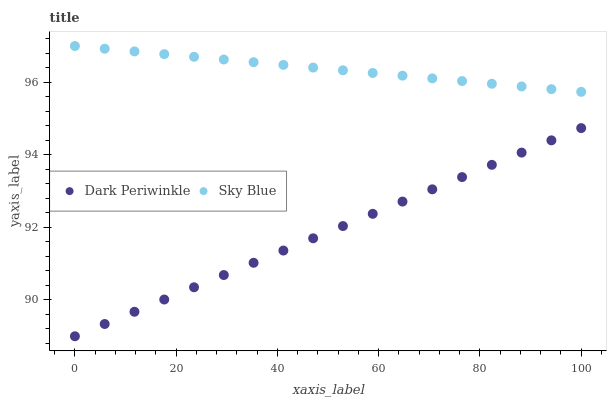Does Dark Periwinkle have the minimum area under the curve?
Answer yes or no. Yes. Does Sky Blue have the maximum area under the curve?
Answer yes or no. Yes. Does Dark Periwinkle have the maximum area under the curve?
Answer yes or no. No. Is Sky Blue the smoothest?
Answer yes or no. Yes. Is Dark Periwinkle the roughest?
Answer yes or no. Yes. Is Dark Periwinkle the smoothest?
Answer yes or no. No. Does Dark Periwinkle have the lowest value?
Answer yes or no. Yes. Does Sky Blue have the highest value?
Answer yes or no. Yes. Does Dark Periwinkle have the highest value?
Answer yes or no. No. Is Dark Periwinkle less than Sky Blue?
Answer yes or no. Yes. Is Sky Blue greater than Dark Periwinkle?
Answer yes or no. Yes. Does Dark Periwinkle intersect Sky Blue?
Answer yes or no. No. 